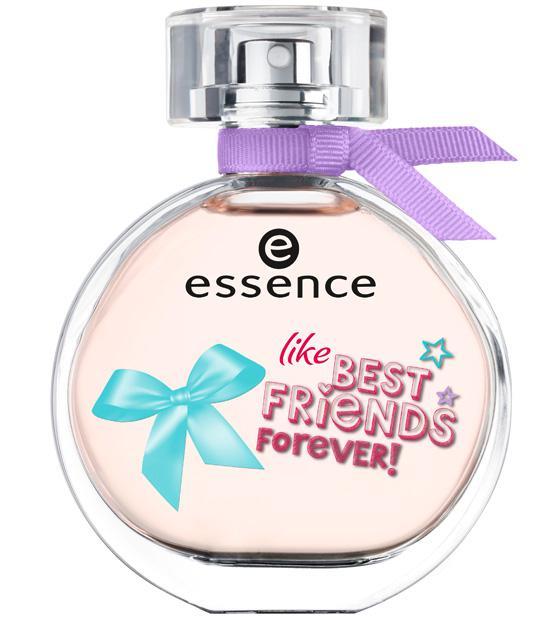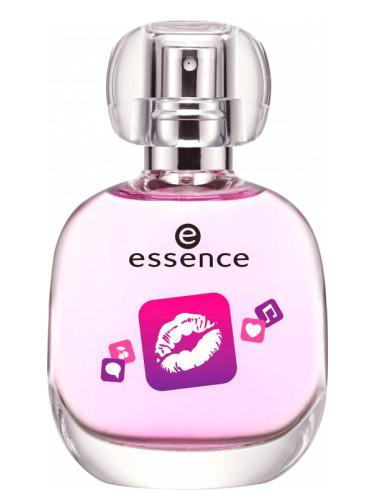The first image is the image on the left, the second image is the image on the right. Evaluate the accuracy of this statement regarding the images: "One bottle has a purple bow.". Is it true? Answer yes or no. Yes. 